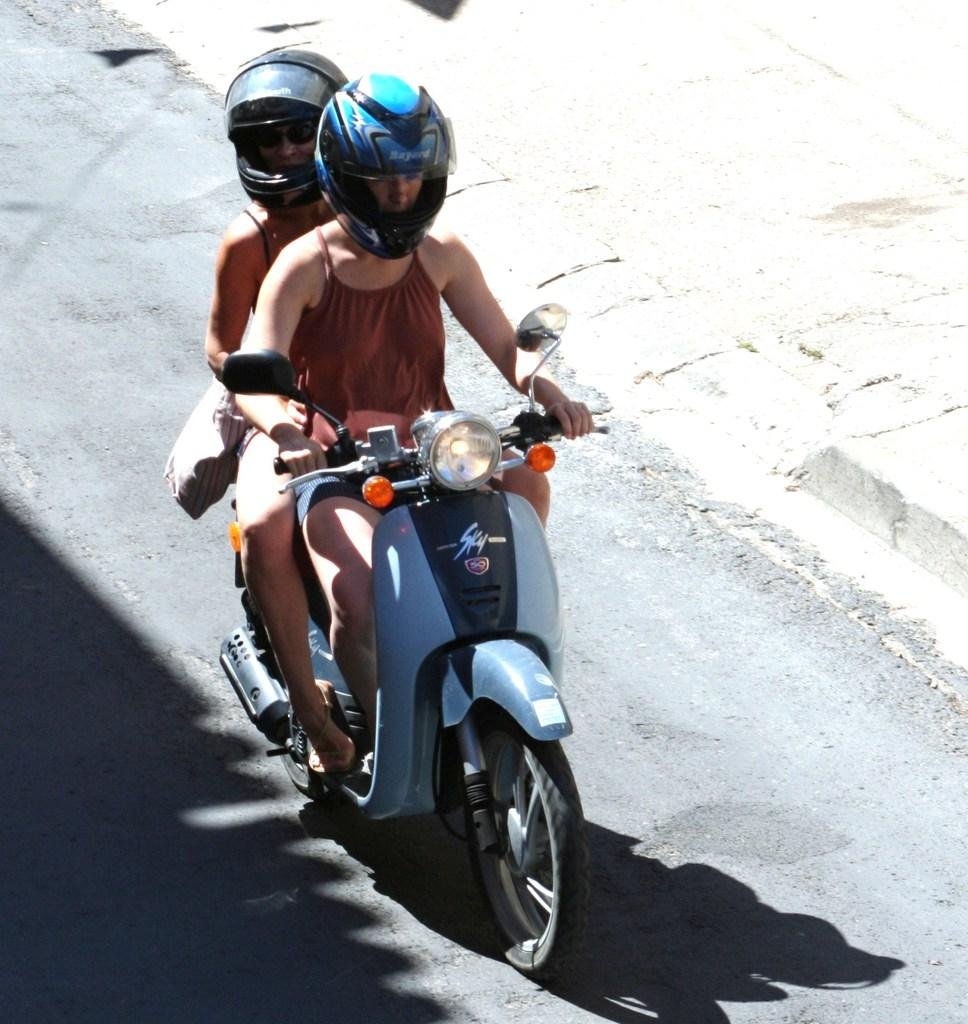How many people are in the image? There are two people in the image. What are the people wearing on their heads? Both people are wearing helmets. What are the people doing in the image? They are riding a motorbike. Where is the motorbike located? The motorbike is on the road. What type of surface is visible next to the road? There is a pavement visible in the image. What type of substance can be seen leaking from the motorbike in the image? There is no substance leaking from the motorbike in the image. How low is the motorbike positioned in the image? The motorbike is not positioned low in the image; it is riding on the road. 